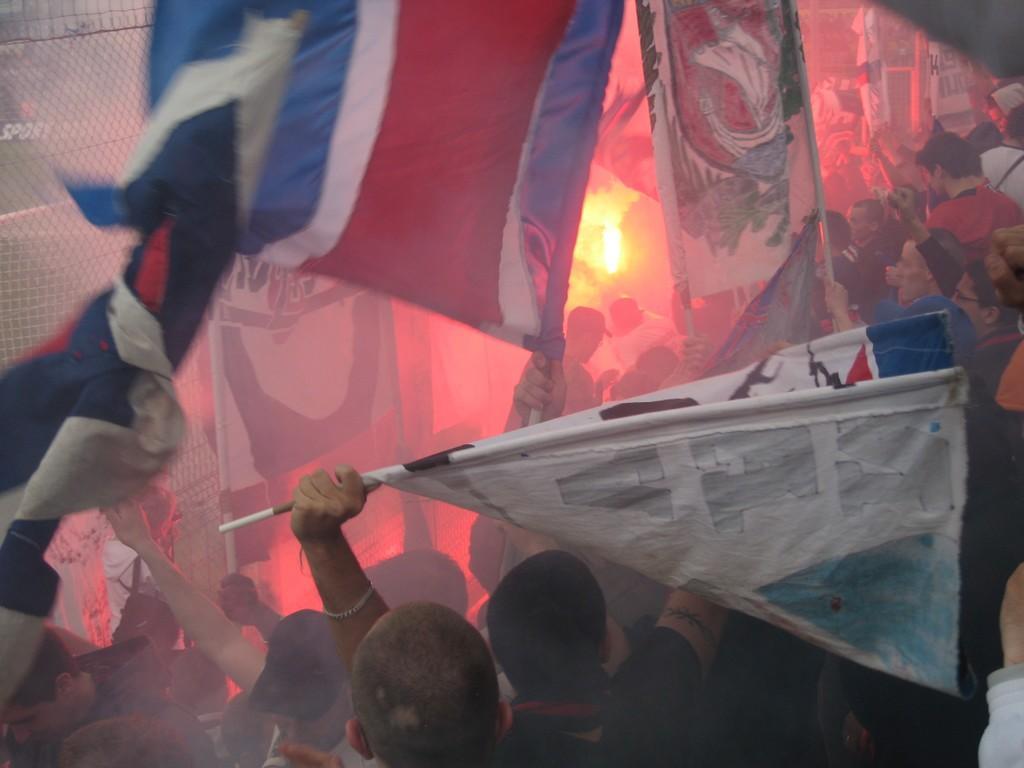Can you describe this image briefly? In this image we can see many people and few people are holding flags in the image. There is a lamp in the image. There is a fencing at the left side of the image. 